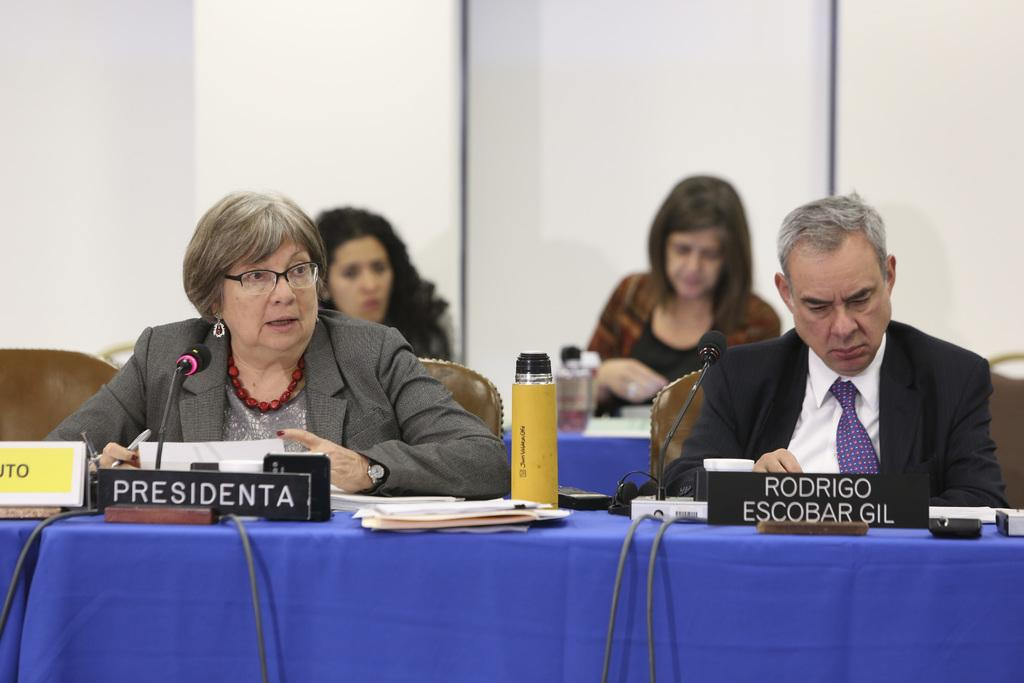What are the persons in the image doing? The persons in the image are sitting on chairs. What is in front of the persons? There is a table in front of the persons. What is covering the table? There is a cloth on the table. What objects are on the table? There is a bottle, a mic, and papers on the table. How does the muscle contribute to the learning process in the image? There is no mention of a muscle or learning process in the image; it features persons sitting at a table with various objects. 